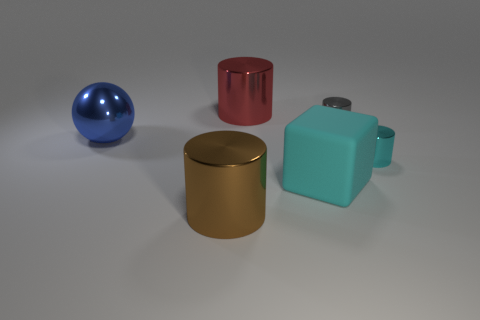Subtract 1 cylinders. How many cylinders are left? 3 Add 2 big rubber blocks. How many objects exist? 8 Subtract all blocks. How many objects are left? 5 Add 2 big metallic things. How many big metallic things are left? 5 Add 3 cubes. How many cubes exist? 4 Subtract 0 purple cylinders. How many objects are left? 6 Subtract all small cubes. Subtract all large cyan rubber cubes. How many objects are left? 5 